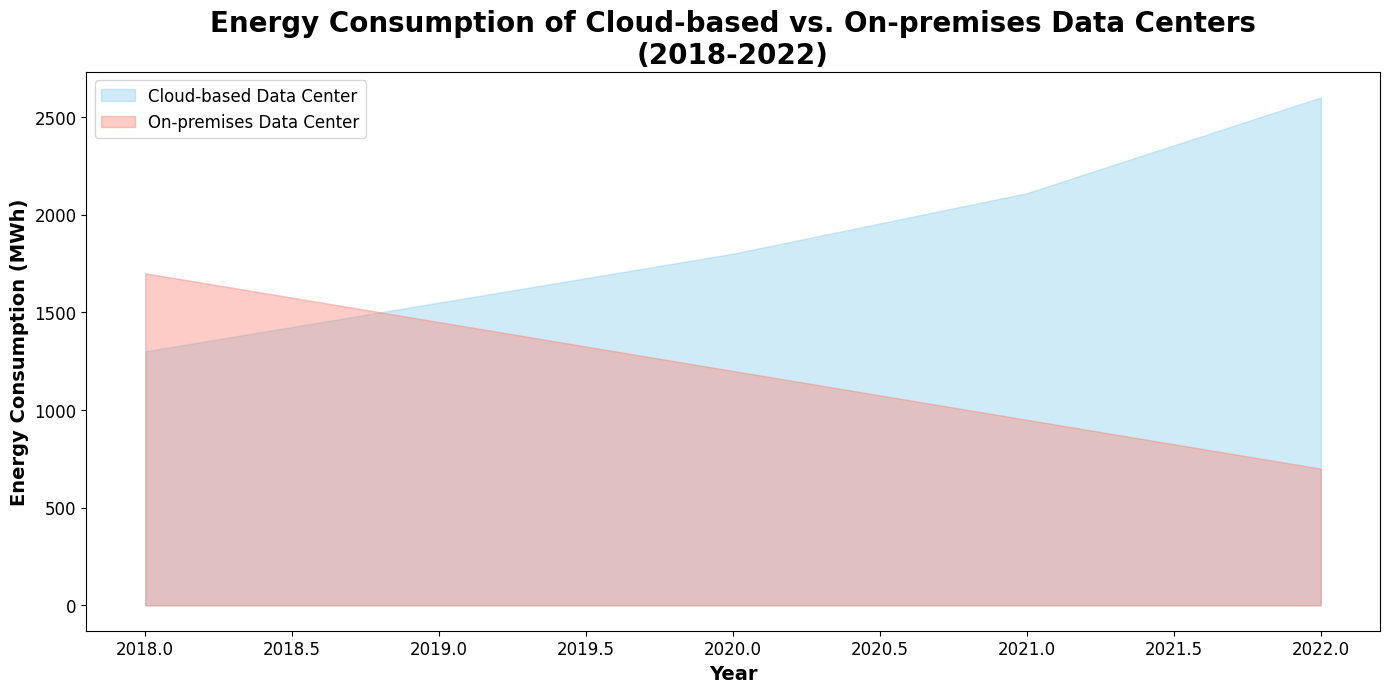How has the energy consumption of cloud-based data centers changed from 2018 to 2022? The area under the blue (skyblue) region representing cloud-based data centers' energy consumption increases from 1200 MWh in 2018 to 2800 MWh in 2022, indicating a rising trend in energy usage over the years.
Answer: Increased Which type of data center had higher energy consumption in 2018? By comparing the heights of the areas in 2018, the red (salmon) region representing on-premises data centers' energy consumption is higher than the blue region, indicating higher energy consumption for on-premises data centers in that year.
Answer: On-premises By how much did the energy consumption of on-premises data centers decrease from 2018 to 2022? In 2018, on-premises energy consumption was approximately 1700 MWh. By 2022, it decreased to around 700 MWh. The difference is 1700 MWh - 700 MWh = 1000 MWh.
Answer: 1000 MWh What was the trend in the energy consumption of on-premises data centers over the 5 years? The area under the red (salmon) region representing on-premises data centers shows a decreasing trend, starting from roughly 1700 MWh in 2018 and declining to about 700 MWh in 2022.
Answer: Decreasing In which year did cloud-based data centers surpass on-premises data centers in terms of energy consumption? By inspecting the crossover of the blue (cloud-based) and red (on-premises) areas, cloud energy consumption surpassed on-premises energy consumption between 2019 and 2020.
Answer: 2020 How does the color of the chart help in differentiating the two types of data centers? The chart uses blue (skyblue) for cloud-based data centers and red (salmon) for on-premises data centers, making it visually easy to distinguish between the two types based on color coding.
Answer: Color coding Can you estimate the average energy consumption of cloud-based data centers over the 5 years? The average energy consumption for cloud-based data centers can be estimated by noting approximate values from the chart at each year: (1300 + 1550 + 1800 + 2100 + 2600) / 5 = 1870 MWh.
Answer: 1870 MWh Do cloud-based or on-premises data centers show more variability in their energy consumption over the years? Cloud-based data centers show a steady increase, while on-premises data centers demonstrate a pronounced decrease. The variability in on-premises consumption is greater due to a steep fall from around 1700 MWh to 700 MWh in the given period.
Answer: On-premises Which year had the lowest energy consumption for on-premises data centers? By examining the bottom points of the red (salmon) region, 2022 shows the lowest energy consumption for on-premises data centers, which is around 700 MWh.
Answer: 2022 